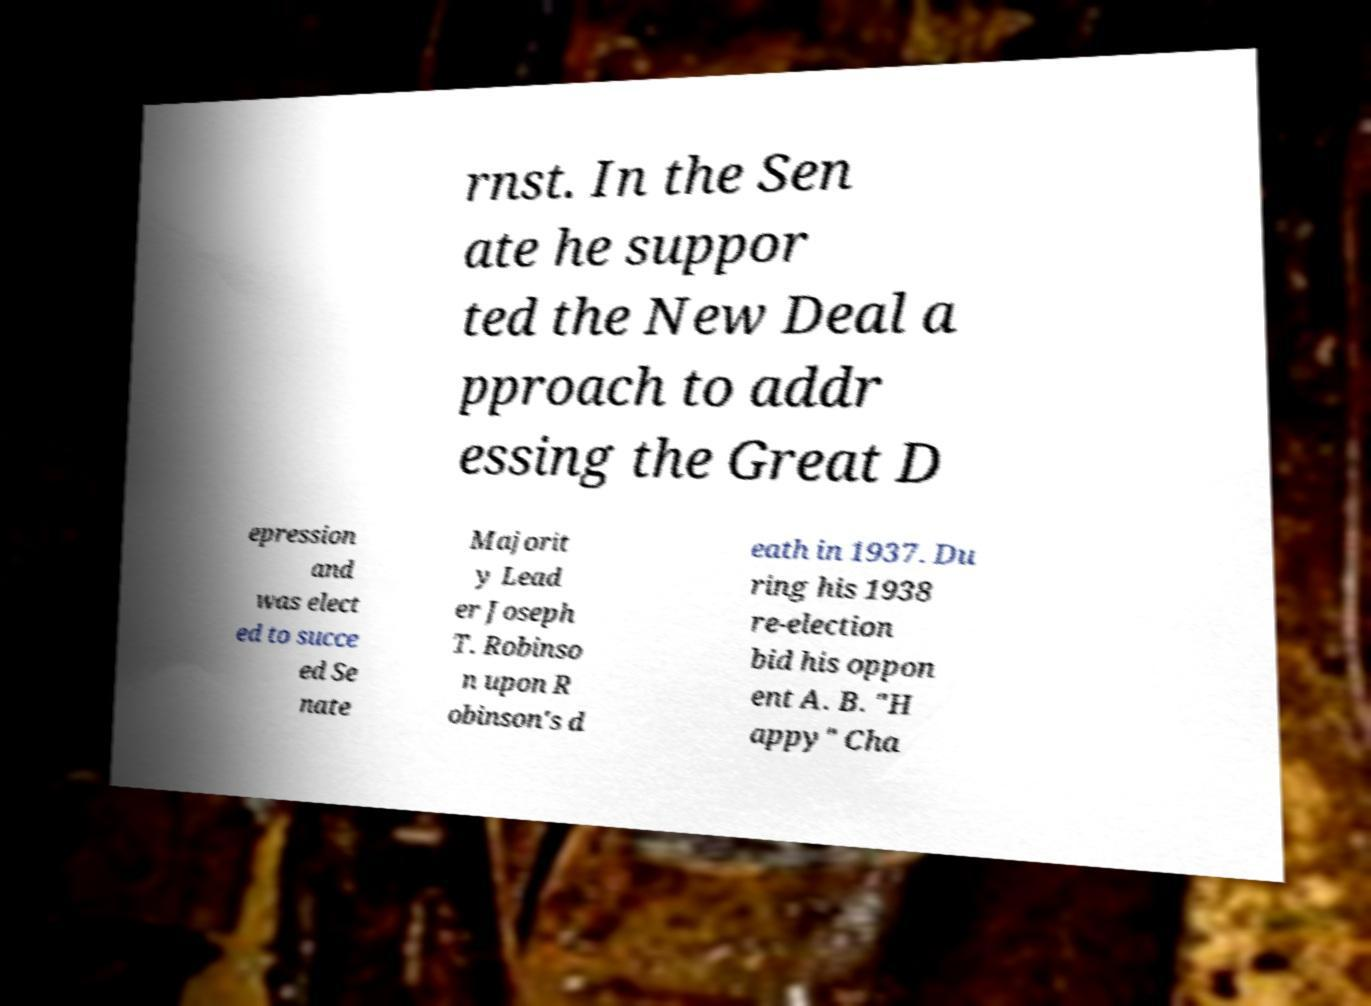Can you accurately transcribe the text from the provided image for me? rnst. In the Sen ate he suppor ted the New Deal a pproach to addr essing the Great D epression and was elect ed to succe ed Se nate Majorit y Lead er Joseph T. Robinso n upon R obinson's d eath in 1937. Du ring his 1938 re-election bid his oppon ent A. B. "H appy" Cha 